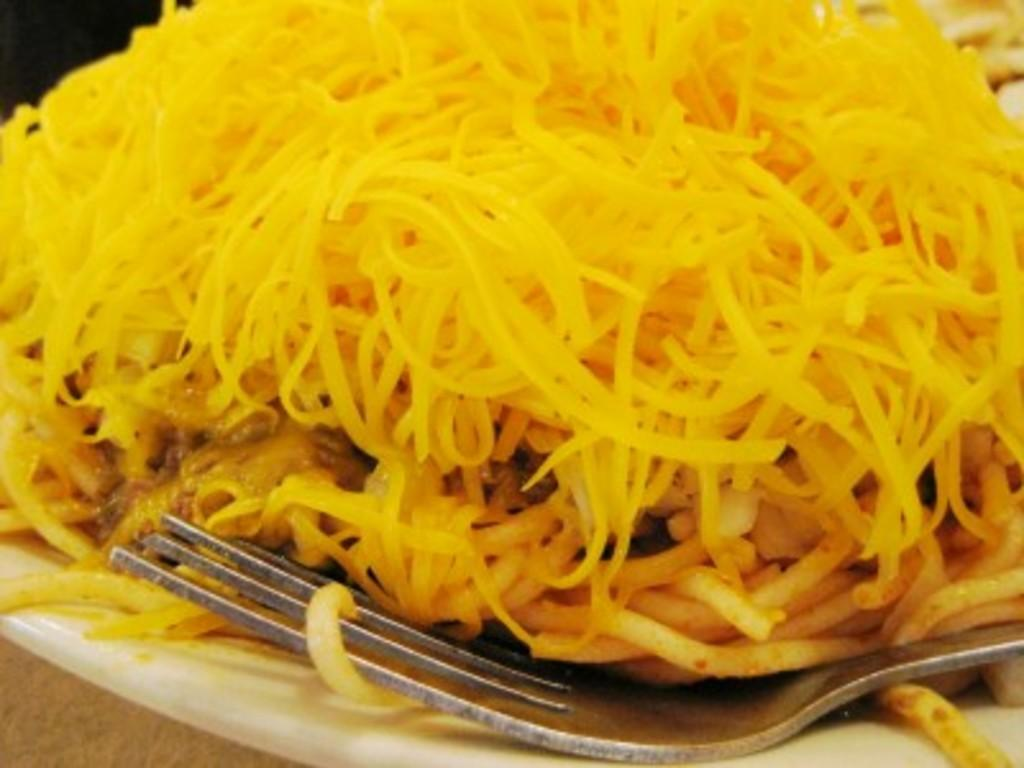What object is present on the plate in the image? There is a fork on the plate in the image. What else can be seen on the plate besides the fork? There is food on the plate in the image. What might be used to eat the food on the plate? The fork on the plate can be used to eat the food. What type of bomb can be seen on the plate in the image? There is no bomb present on the plate in the image; it only contains a fork and food. 